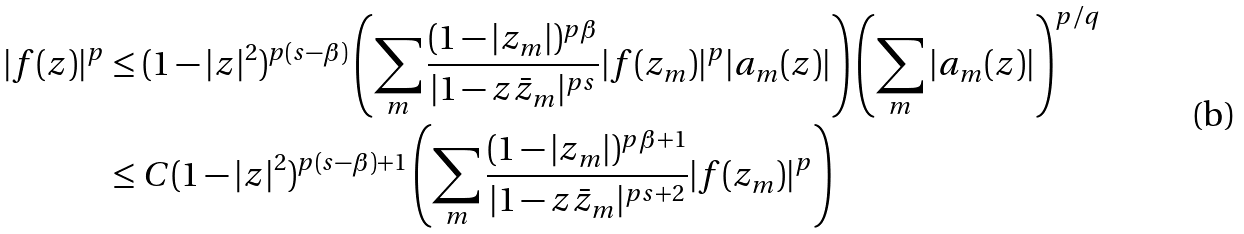<formula> <loc_0><loc_0><loc_500><loc_500>| f ( z ) | ^ { p } & \leq ( 1 - | z | ^ { 2 } ) ^ { p ( s - \beta ) } \left ( \sum _ { m } \frac { ( 1 - | z _ { m } | ) ^ { p \beta } } { | 1 - z \bar { z } _ { m } | ^ { p s } } | f ( z _ { m } ) | ^ { p } | a _ { m } ( z ) | \right ) \left ( \sum _ { m } | a _ { m } ( z ) | \right ) ^ { p / q } \\ & \leq C ( 1 - | z | ^ { 2 } ) ^ { p ( s - \beta ) + 1 } \left ( \sum _ { m } \frac { ( 1 - | z _ { m } | ) ^ { p \beta + 1 } } { | 1 - z \bar { z } _ { m } | ^ { p s + 2 } } | f ( z _ { m } ) | ^ { p } \right )</formula> 